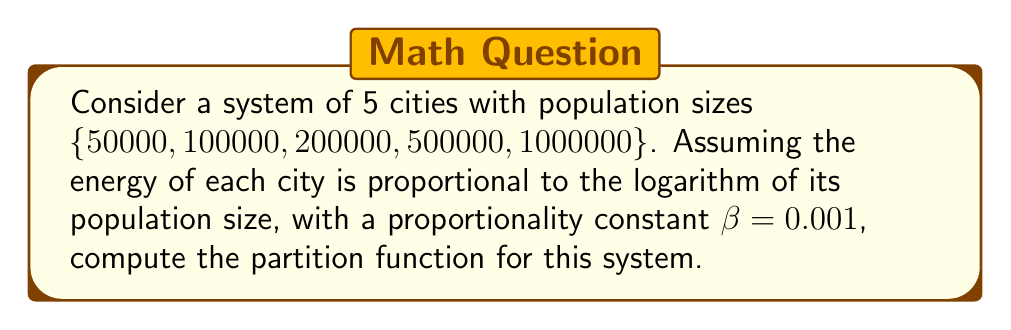Solve this math problem. To solve this problem, we'll follow these steps:

1) The partition function $Z$ is defined as:

   $$Z = \sum_{i} e^{-\beta E_i}$$

   where $E_i$ is the energy of each state and $\beta$ is the inverse temperature.

2) In this case, the energy of each city is proportional to the logarithm of its population:

   $$E_i = \beta \ln(N_i)$$

   where $N_i$ is the population of city $i$.

3) Substituting this into the partition function formula:

   $$Z = \sum_{i} e^{-\beta (\beta \ln(N_i))} = \sum_{i} e^{-\beta^2 \ln(N_i)}$$

4) Using the properties of logarithms and exponents:

   $$Z = \sum_{i} (N_i)^{-\beta^2}$$

5) Now, let's calculate for each city:

   For $N_1 = 50000$:  $(50000)^{-(0.001)^2} = 0.9949$
   For $N_2 = 100000$: $(100000)^{-(0.001)^2} = 0.9943$
   For $N_3 = 200000$: $(200000)^{-(0.001)^2} = 0.9937$
   For $N_4 = 500000$: $(500000)^{-(0.001)^2} = 0.9929$
   For $N_5 = 1000000$: $(1000000)^{-(0.001)^2} = 0.9923$

6) The partition function is the sum of these values:

   $$Z = 0.9949 + 0.9943 + 0.9937 + 0.9929 + 0.9923 = 4.9681$$
Answer: $Z \approx 4.9681$ 